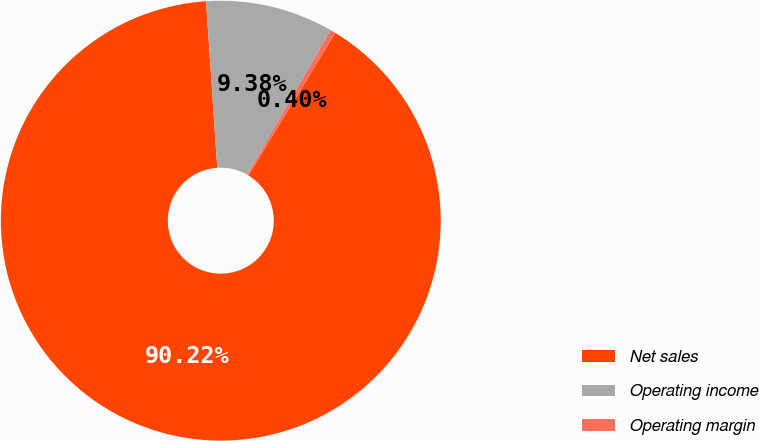Convert chart. <chart><loc_0><loc_0><loc_500><loc_500><pie_chart><fcel>Net sales<fcel>Operating income<fcel>Operating margin<nl><fcel>90.21%<fcel>9.38%<fcel>0.4%<nl></chart> 